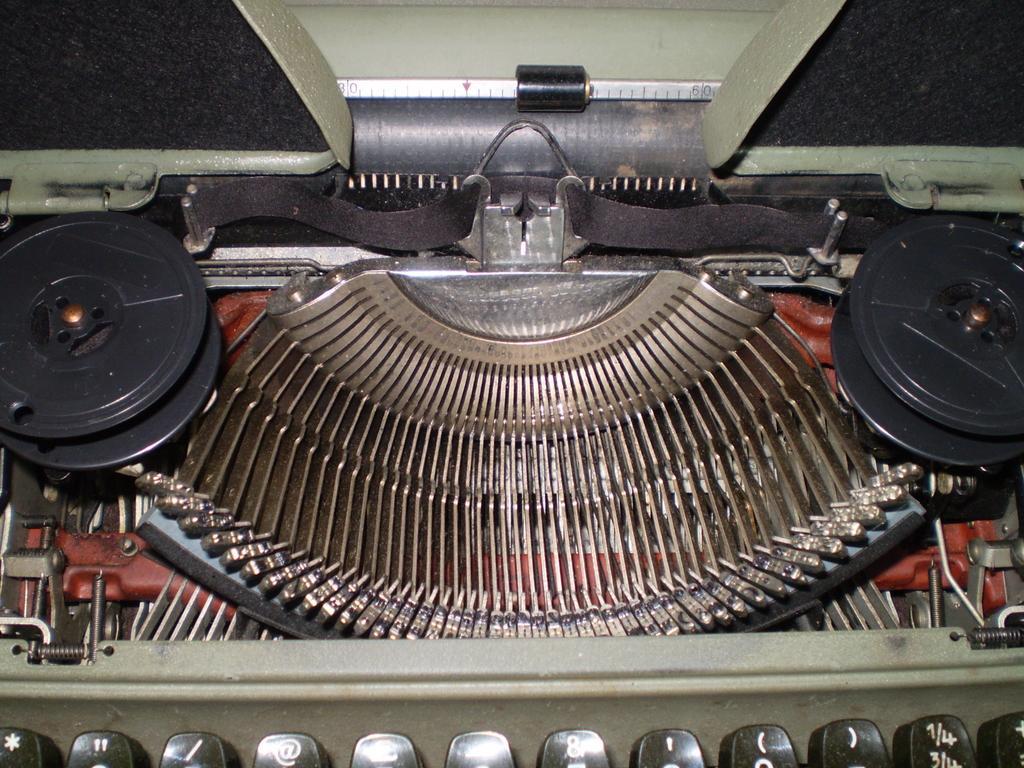In one or two sentences, can you explain what this image depicts? In the picture we can see a typewriter machine with a ribbon spool, key top and some keys which are black in color. 